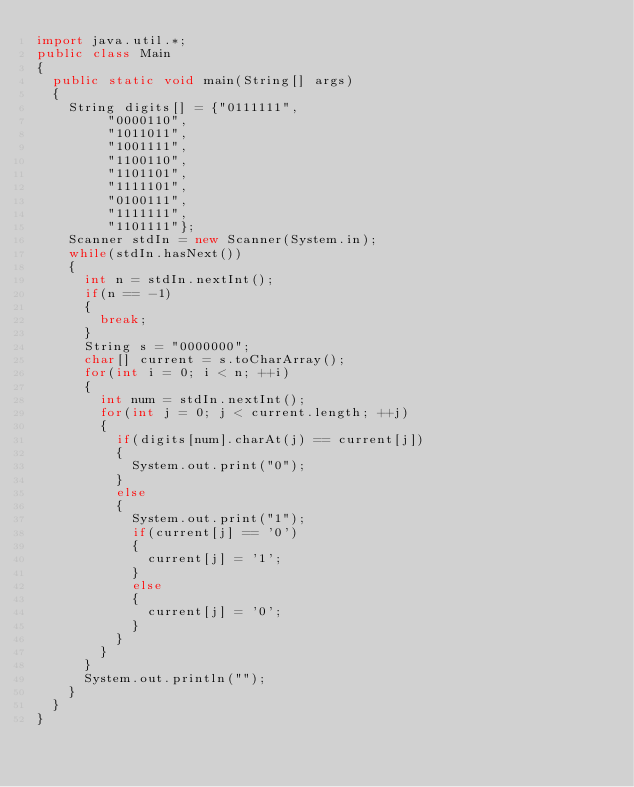<code> <loc_0><loc_0><loc_500><loc_500><_Java_>import java.util.*;
public class Main 
{
	public static void main(String[] args) 
	{
		String digits[] = {"0111111", 
				 "0000110", 
				 "1011011", 
				 "1001111", 
				 "1100110", 
				 "1101101", 
				 "1111101", 
				 "0100111", 
				 "1111111", 
				 "1101111"};
		Scanner stdIn = new Scanner(System.in);
		while(stdIn.hasNext())
		{
			int n = stdIn.nextInt();
			if(n == -1)
			{
				break;
			}
			String s = "0000000";
			char[] current = s.toCharArray();
			for(int i = 0; i < n; ++i)
			{
				int num = stdIn.nextInt();
				for(int j = 0; j < current.length; ++j)
				{
					if(digits[num].charAt(j) == current[j])
					{
						System.out.print("0");
					}
					else
					{
						System.out.print("1");
						if(current[j] == '0')
						{
							current[j] = '1';
						}
						else
						{
							current[j] = '0';
						}
					}
				}
			}
			System.out.println("");
		}
	}
}</code> 